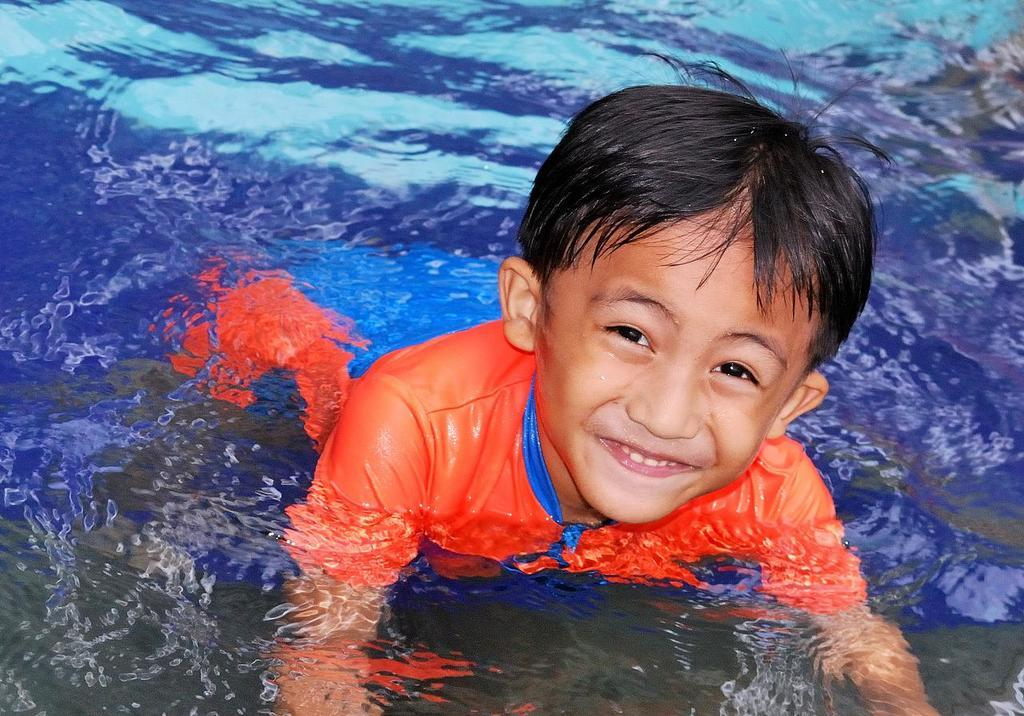What is the main subject of the image? The main subject of the image is a kid. Where is the kid located in the image? The kid is in the water. What can be seen in the background of the image? There is water visible in the background of the image. What type of rake is the kid using to collect rocks in the image? There is no rake or rocks present in the image; it features a kid in the water. 